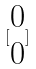<formula> <loc_0><loc_0><loc_500><loc_500>[ \begin{matrix} 0 \\ 0 \end{matrix} ]</formula> 